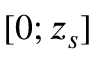<formula> <loc_0><loc_0><loc_500><loc_500>[ 0 ; z _ { s } ]</formula> 